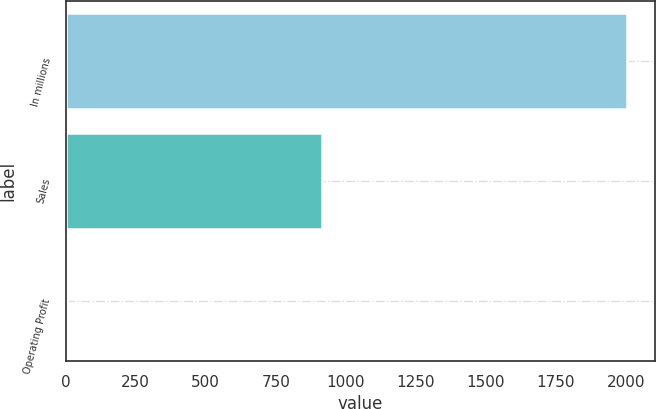<chart> <loc_0><loc_0><loc_500><loc_500><bar_chart><fcel>In millions<fcel>Sales<fcel>Operating Profit<nl><fcel>2005<fcel>915<fcel>4<nl></chart> 